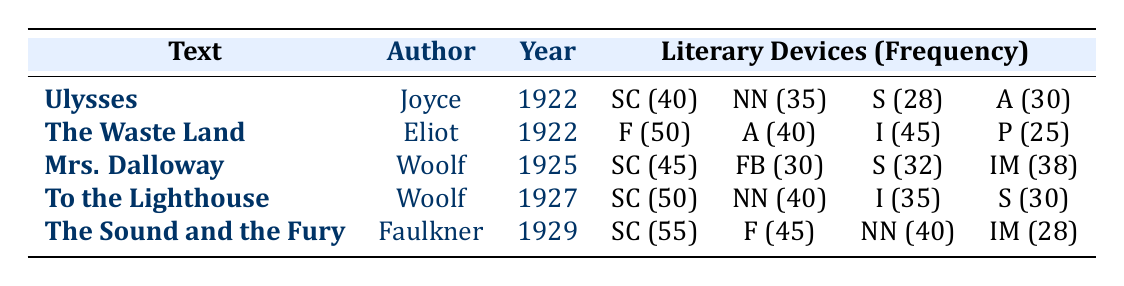What is the frequency of stream of consciousness in "The Sound and the Fury"? The table shows that "The Sound and the Fury" by William Faulkner has a frequency of 55 for the literary device of stream of consciousness.
Answer: 55 Which modernist literary device appears most frequently in "The Waste Land"? In "The Waste Land," the most frequent literary device is fragmentation, with a frequency of 50.
Answer: 50 How many literary devices are listed for "Mrs. Dalloway"? "Mrs. Dalloway" has four literary devices listed: stream of consciousness, flashback, symbolism, and interior monologue.
Answer: Four What is the average frequency of allusion across the texts? To find the average frequency of allusion, we sum the frequencies: 30 (Ulysses) + 40 (The Waste Land) + 0 (Mrs. Dalloway) + 0 (To the Lighthouse) + 0 (The Sound and the Fury) = 70, and there are three texts that feature allusion, which yields an average of 70/3 = approximately 23.33.
Answer: 23.33 Is there a text that features both nonlinear narrative and stream of consciousness by the same author? Yes, "To the Lighthouse" by Virginia Woolf features both nonlinear narrative and stream of consciousness.
Answer: Yes What is the total frequency of documentary devices in "Ulysses" and "The Waste Land"? In "Ulysses," the frequencies of documentary devices are: allusion (30), while in "The Waste Land," they are: allusion (40) and fragmentation (50). The sum for "Ulysses" and "The Waste Land" is 30 + 40 + 50 = 120.
Answer: 120 Which author had the highest frequency of interior monologue, and what is that frequency? The highest frequency of interior monologue is in "Mrs. Dalloway" by Virginia Woolf, with a frequency of 38.
Answer: 38 What is the difference in frequency of imagery between "The Waste Land" and "To the Lighthouse"? "The Waste Land" has an imagery frequency of 45, while "To the Lighthouse" has a frequency of 35. The difference is 45 - 35 = 10.
Answer: 10 Are the frequencies of nonlinear narrative and fragmentation the same in "Ulysses" and "The Sound and the Fury"? No, the frequency of nonlinear narrative in "Ulysses" is 35, while in "The Sound and the Fury" it is 40, so they are not the same.
Answer: No 